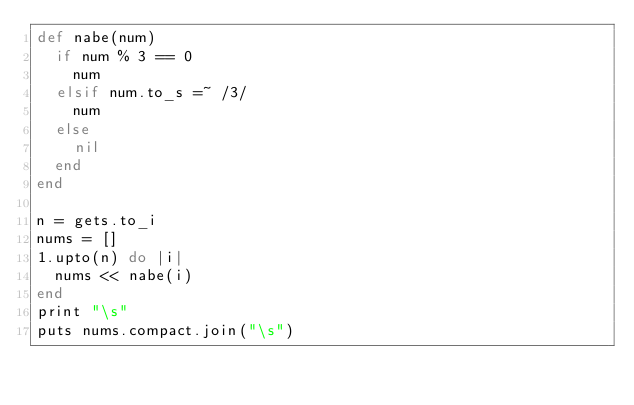<code> <loc_0><loc_0><loc_500><loc_500><_Ruby_>def nabe(num)
  if num % 3 == 0
    num
  elsif num.to_s =~ /3/
    num
  else
    nil
  end
end

n = gets.to_i
nums = []
1.upto(n) do |i|
  nums << nabe(i)
end
print "\s"
puts nums.compact.join("\s")</code> 